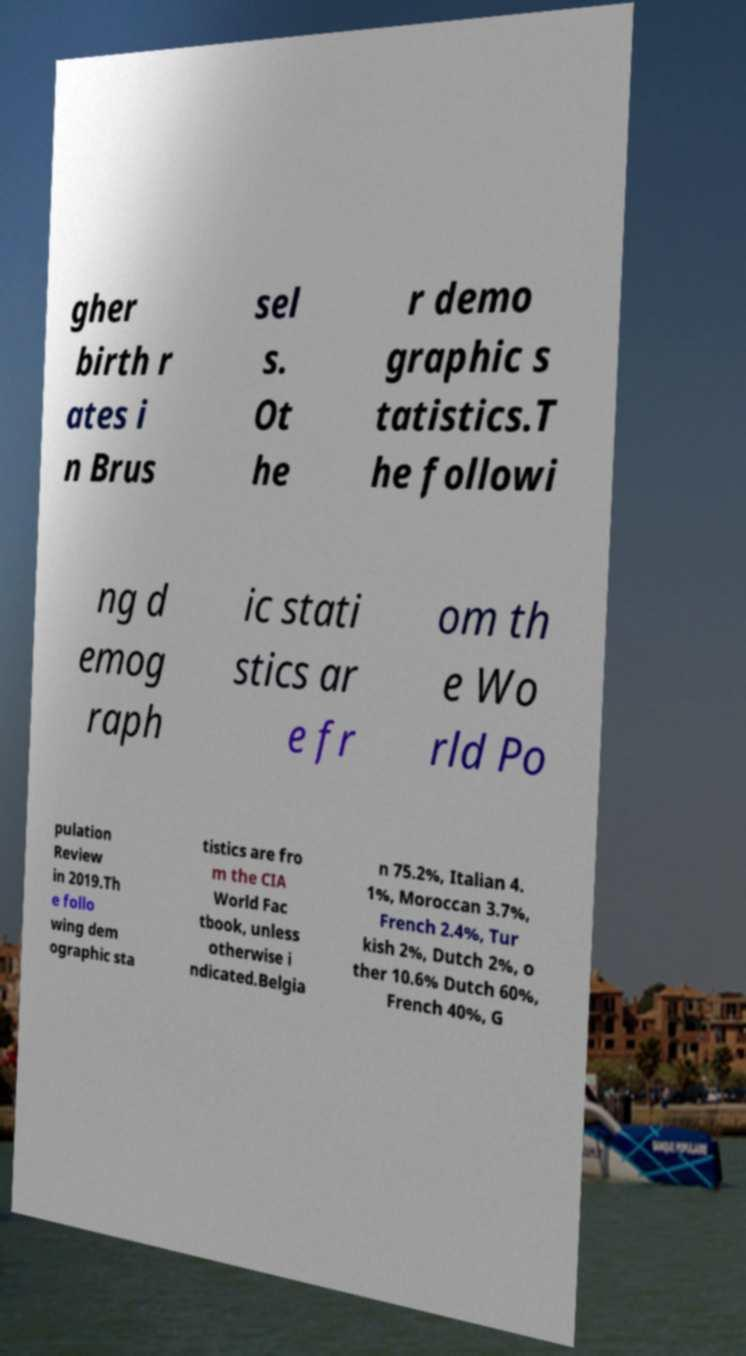For documentation purposes, I need the text within this image transcribed. Could you provide that? gher birth r ates i n Brus sel s. Ot he r demo graphic s tatistics.T he followi ng d emog raph ic stati stics ar e fr om th e Wo rld Po pulation Review in 2019.Th e follo wing dem ographic sta tistics are fro m the CIA World Fac tbook, unless otherwise i ndicated.Belgia n 75.2%, Italian 4. 1%, Moroccan 3.7%, French 2.4%, Tur kish 2%, Dutch 2%, o ther 10.6% Dutch 60%, French 40%, G 